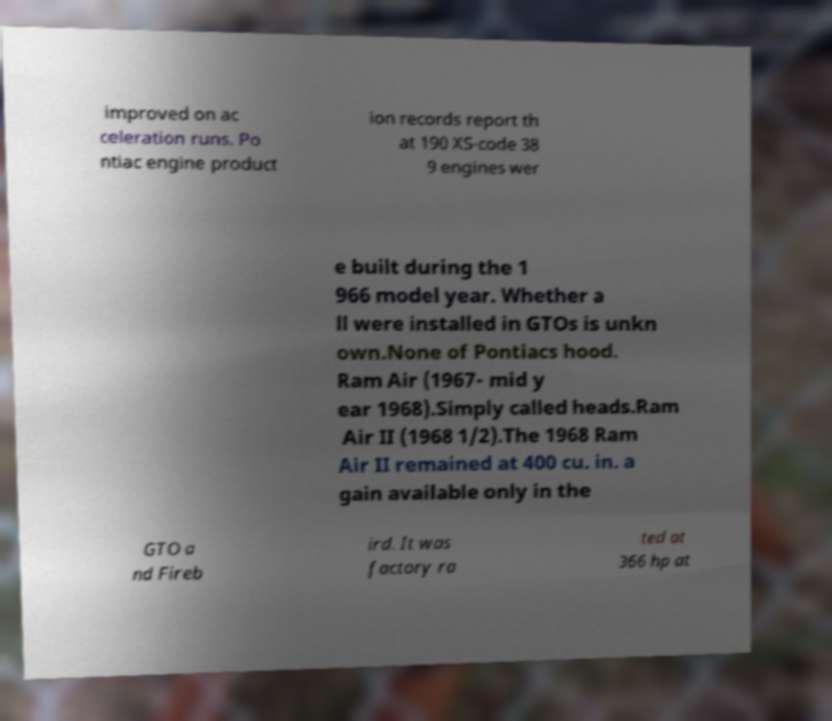Can you accurately transcribe the text from the provided image for me? improved on ac celeration runs. Po ntiac engine product ion records report th at 190 XS-code 38 9 engines wer e built during the 1 966 model year. Whether a ll were installed in GTOs is unkn own.None of Pontiacs hood. Ram Air (1967- mid y ear 1968).Simply called heads.Ram Air II (1968 1/2).The 1968 Ram Air II remained at 400 cu. in. a gain available only in the GTO a nd Fireb ird. It was factory ra ted at 366 hp at 